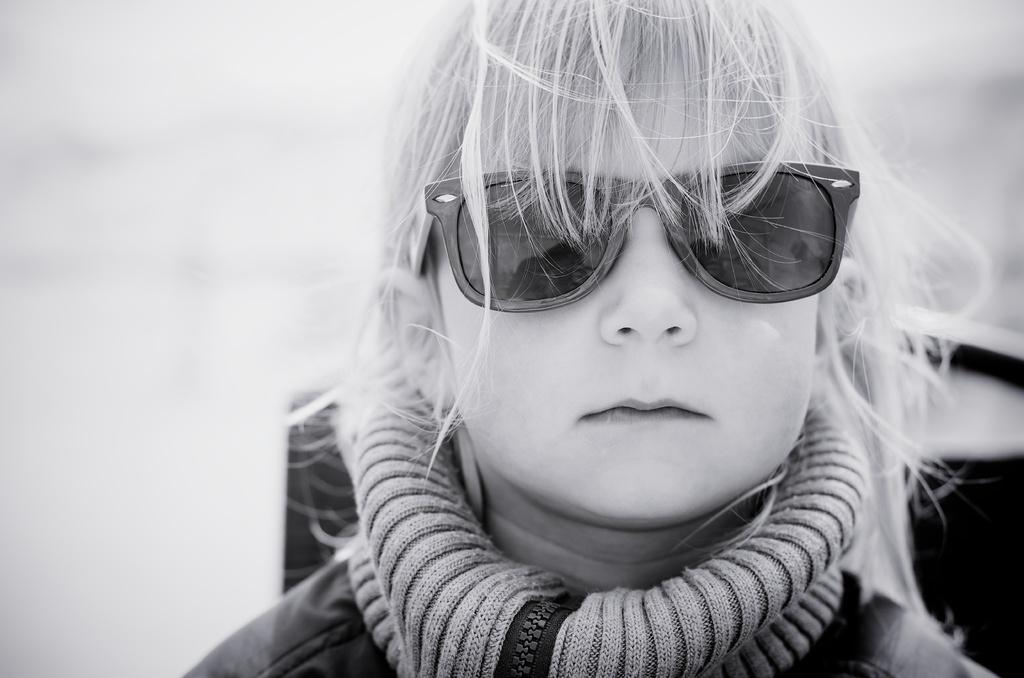What is the main subject of the image? The main subject of the image is a small girl. Where is the small girl located in the image? The small girl is on the right side of the image. What type of patch is the small girl wearing on her clothes in the image? There is no patch visible on the small girl's clothes in the image. What is the small girl saying to someone as they are leaving in the image? There is no indication of a conversation or good-bye in the image. What type of brake system is visible on the small girl's bicycle in the image? There is no bicycle or brake system visible in the image. 